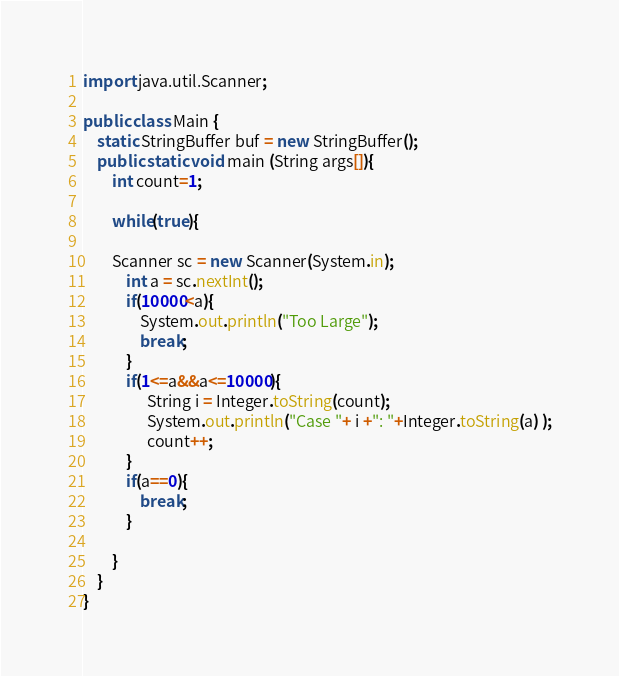Convert code to text. <code><loc_0><loc_0><loc_500><loc_500><_Java_>import java.util.Scanner;

public class Main {
	static StringBuffer buf = new StringBuffer();
    public static void main (String args[]){
    	int count=1;

    	while(true){

        Scanner sc = new Scanner(System.in);
    	    int a = sc.nextInt();
    	    if(10000<a){
    	    	System.out.println("Too Large");
    	    	break;
    	    }
    	    if(1<=a&&a<=10000){
                  String i = Integer.toString(count);
                  System.out.println("Case "+ i +": "+Integer.toString(a) );
                  count++;
    	    }
    	    if(a==0){
    	    	break;
    	    }

    	}
    }
}</code> 